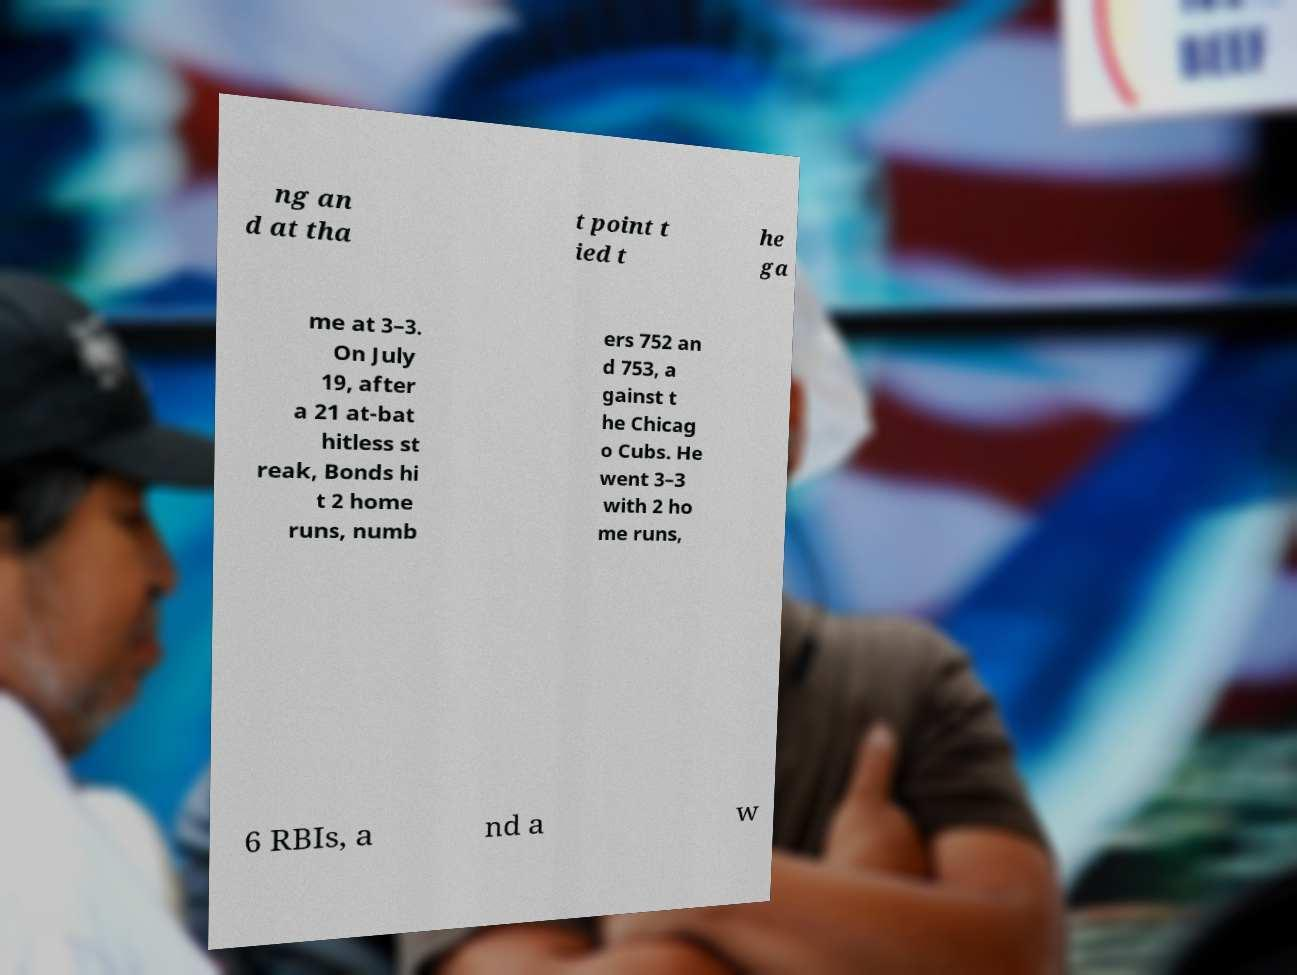Please read and relay the text visible in this image. What does it say? ng an d at tha t point t ied t he ga me at 3–3. On July 19, after a 21 at-bat hitless st reak, Bonds hi t 2 home runs, numb ers 752 an d 753, a gainst t he Chicag o Cubs. He went 3–3 with 2 ho me runs, 6 RBIs, a nd a w 